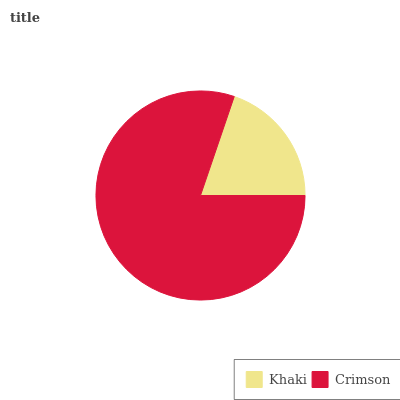Is Khaki the minimum?
Answer yes or no. Yes. Is Crimson the maximum?
Answer yes or no. Yes. Is Crimson the minimum?
Answer yes or no. No. Is Crimson greater than Khaki?
Answer yes or no. Yes. Is Khaki less than Crimson?
Answer yes or no. Yes. Is Khaki greater than Crimson?
Answer yes or no. No. Is Crimson less than Khaki?
Answer yes or no. No. Is Crimson the high median?
Answer yes or no. Yes. Is Khaki the low median?
Answer yes or no. Yes. Is Khaki the high median?
Answer yes or no. No. Is Crimson the low median?
Answer yes or no. No. 